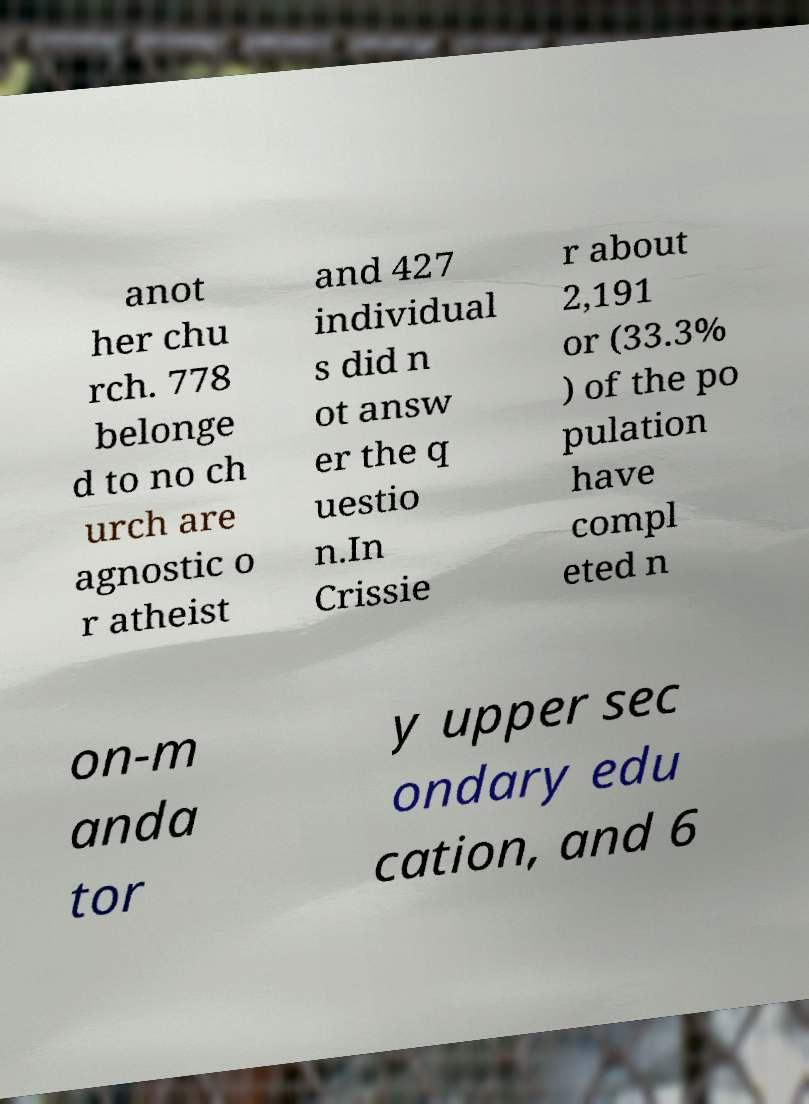Could you assist in decoding the text presented in this image and type it out clearly? anot her chu rch. 778 belonge d to no ch urch are agnostic o r atheist and 427 individual s did n ot answ er the q uestio n.In Crissie r about 2,191 or (33.3% ) of the po pulation have compl eted n on-m anda tor y upper sec ondary edu cation, and 6 